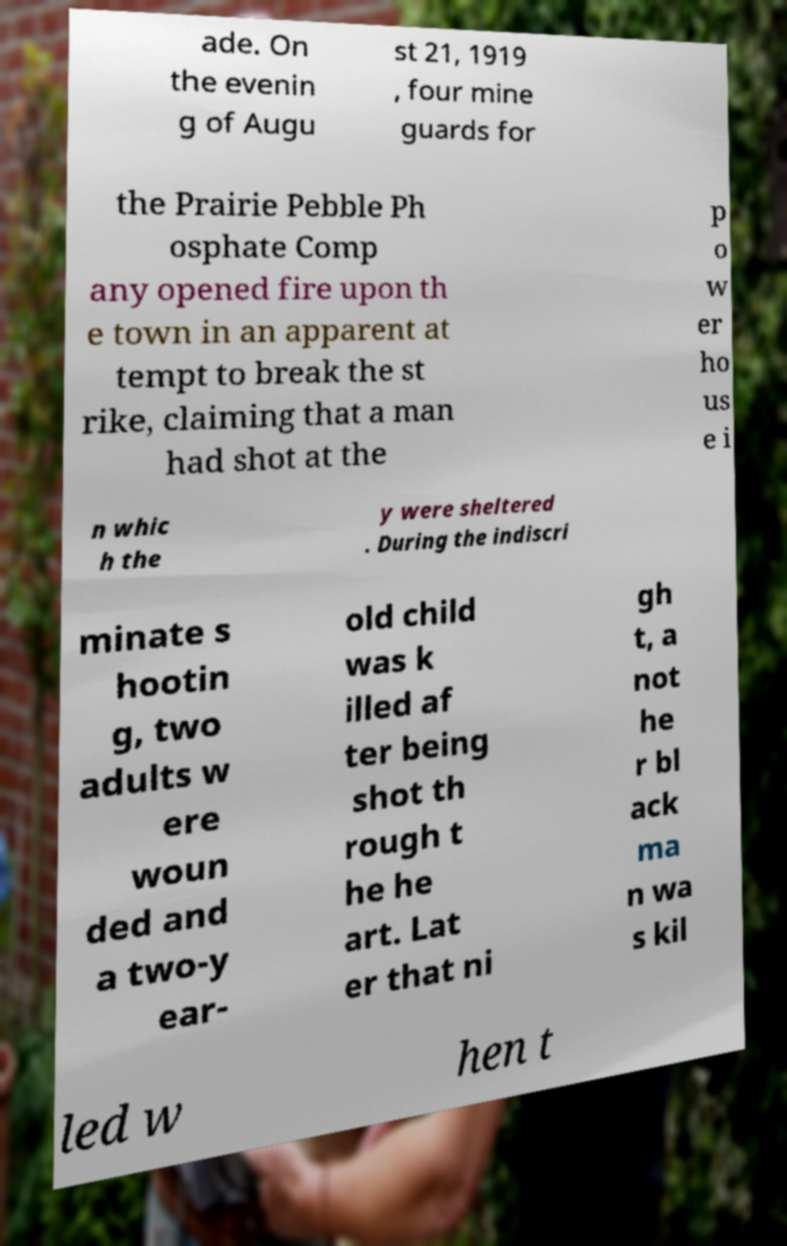Please identify and transcribe the text found in this image. ade. On the evenin g of Augu st 21, 1919 , four mine guards for the Prairie Pebble Ph osphate Comp any opened fire upon th e town in an apparent at tempt to break the st rike, claiming that a man had shot at the p o w er ho us e i n whic h the y were sheltered . During the indiscri minate s hootin g, two adults w ere woun ded and a two-y ear- old child was k illed af ter being shot th rough t he he art. Lat er that ni gh t, a not he r bl ack ma n wa s kil led w hen t 